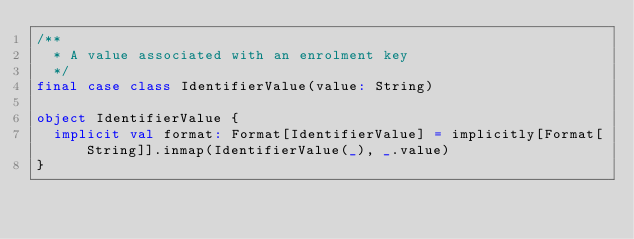<code> <loc_0><loc_0><loc_500><loc_500><_Scala_>/**
  * A value associated with an enrolment key
  */
final case class IdentifierValue(value: String)

object IdentifierValue {
  implicit val format: Format[IdentifierValue] = implicitly[Format[String]].inmap(IdentifierValue(_), _.value)
}
</code> 